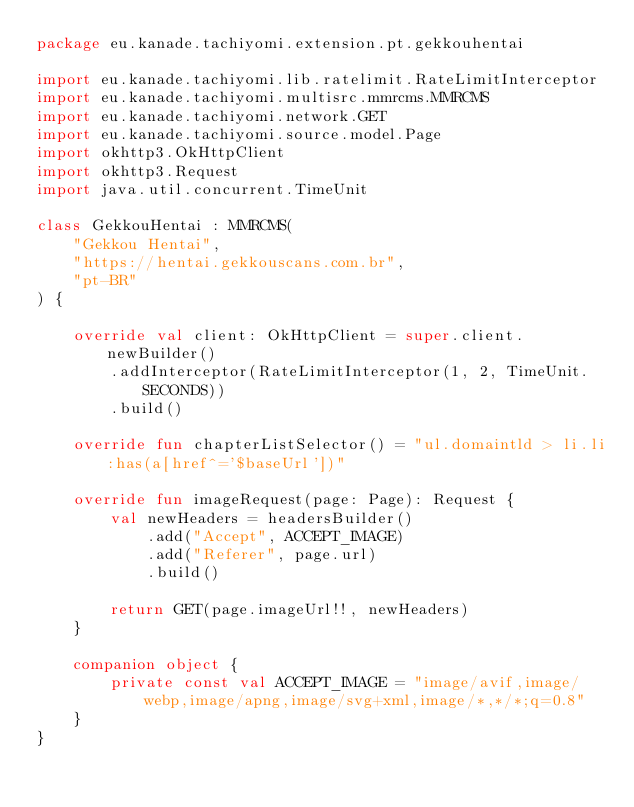Convert code to text. <code><loc_0><loc_0><loc_500><loc_500><_Kotlin_>package eu.kanade.tachiyomi.extension.pt.gekkouhentai

import eu.kanade.tachiyomi.lib.ratelimit.RateLimitInterceptor
import eu.kanade.tachiyomi.multisrc.mmrcms.MMRCMS
import eu.kanade.tachiyomi.network.GET
import eu.kanade.tachiyomi.source.model.Page
import okhttp3.OkHttpClient
import okhttp3.Request
import java.util.concurrent.TimeUnit

class GekkouHentai : MMRCMS(
    "Gekkou Hentai",
    "https://hentai.gekkouscans.com.br",
    "pt-BR"
) {

    override val client: OkHttpClient = super.client.newBuilder()
        .addInterceptor(RateLimitInterceptor(1, 2, TimeUnit.SECONDS))
        .build()

    override fun chapterListSelector() = "ul.domaintld > li.li:has(a[href^='$baseUrl'])"

    override fun imageRequest(page: Page): Request {
        val newHeaders = headersBuilder()
            .add("Accept", ACCEPT_IMAGE)
            .add("Referer", page.url)
            .build()

        return GET(page.imageUrl!!, newHeaders)
    }

    companion object {
        private const val ACCEPT_IMAGE = "image/avif,image/webp,image/apng,image/svg+xml,image/*,*/*;q=0.8"
    }
}
</code> 